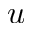<formula> <loc_0><loc_0><loc_500><loc_500>u</formula> 